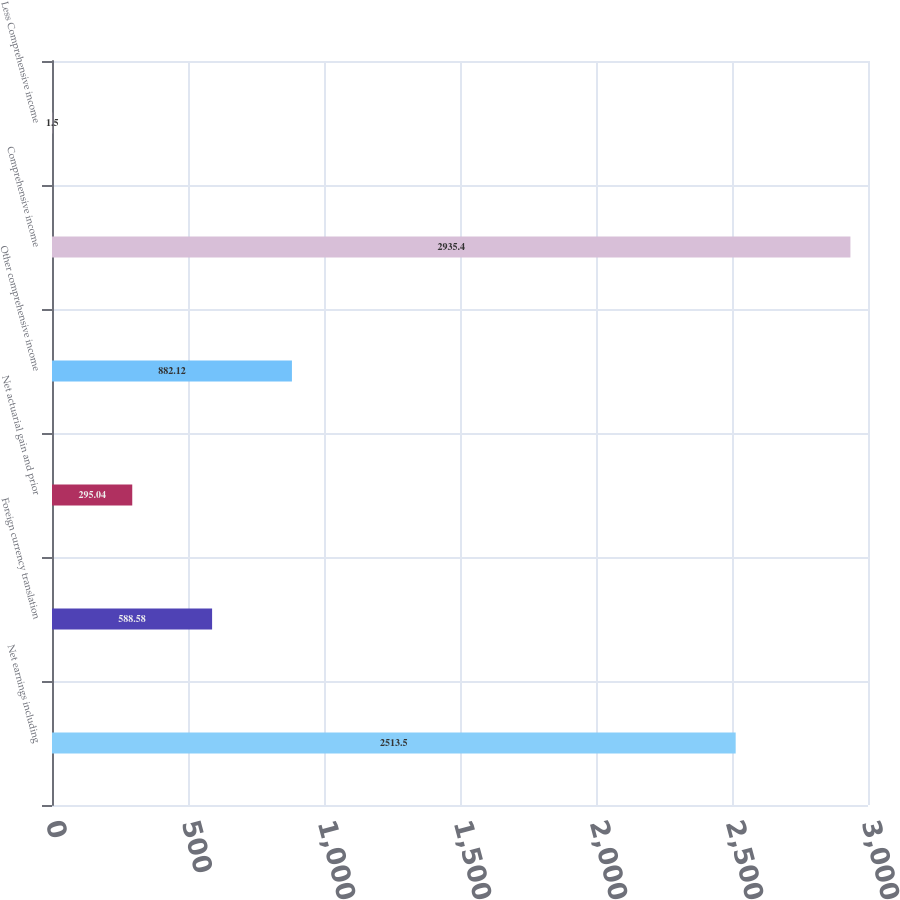Convert chart. <chart><loc_0><loc_0><loc_500><loc_500><bar_chart><fcel>Net earnings including<fcel>Foreign currency translation<fcel>Net actuarial gain and prior<fcel>Other comprehensive income<fcel>Comprehensive income<fcel>Less Comprehensive income<nl><fcel>2513.5<fcel>588.58<fcel>295.04<fcel>882.12<fcel>2935.4<fcel>1.5<nl></chart> 